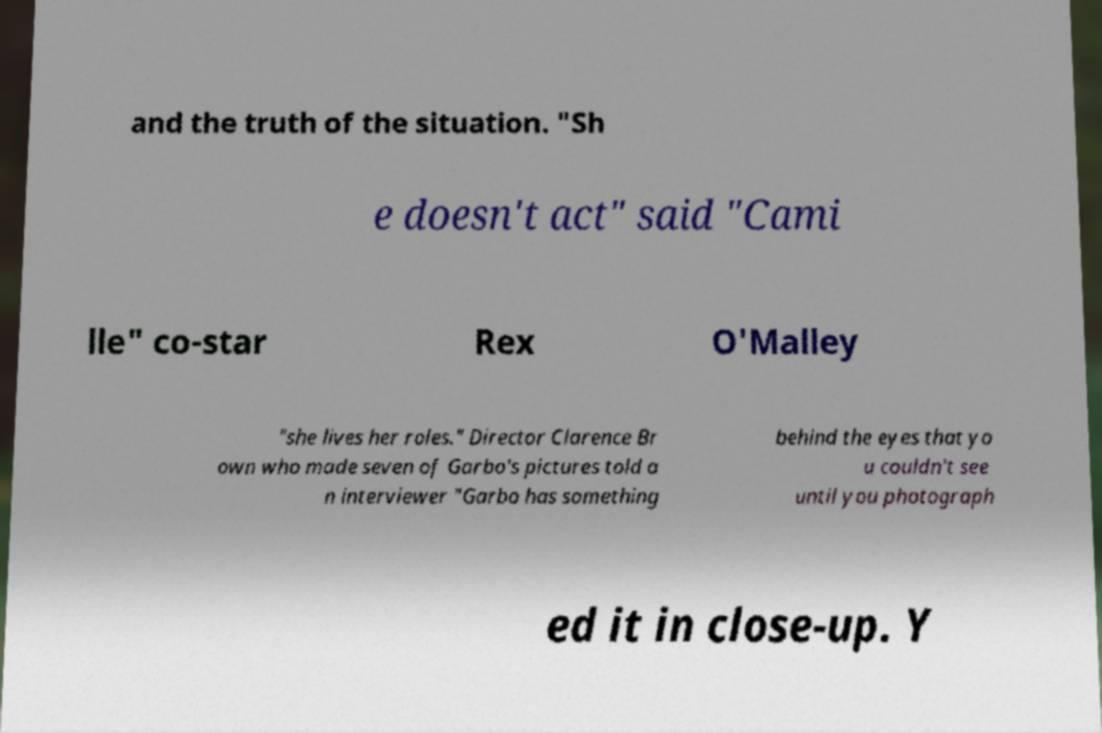Can you read and provide the text displayed in the image?This photo seems to have some interesting text. Can you extract and type it out for me? and the truth of the situation. "Sh e doesn't act" said "Cami lle" co-star Rex O'Malley "she lives her roles." Director Clarence Br own who made seven of Garbo's pictures told a n interviewer "Garbo has something behind the eyes that yo u couldn't see until you photograph ed it in close-up. Y 